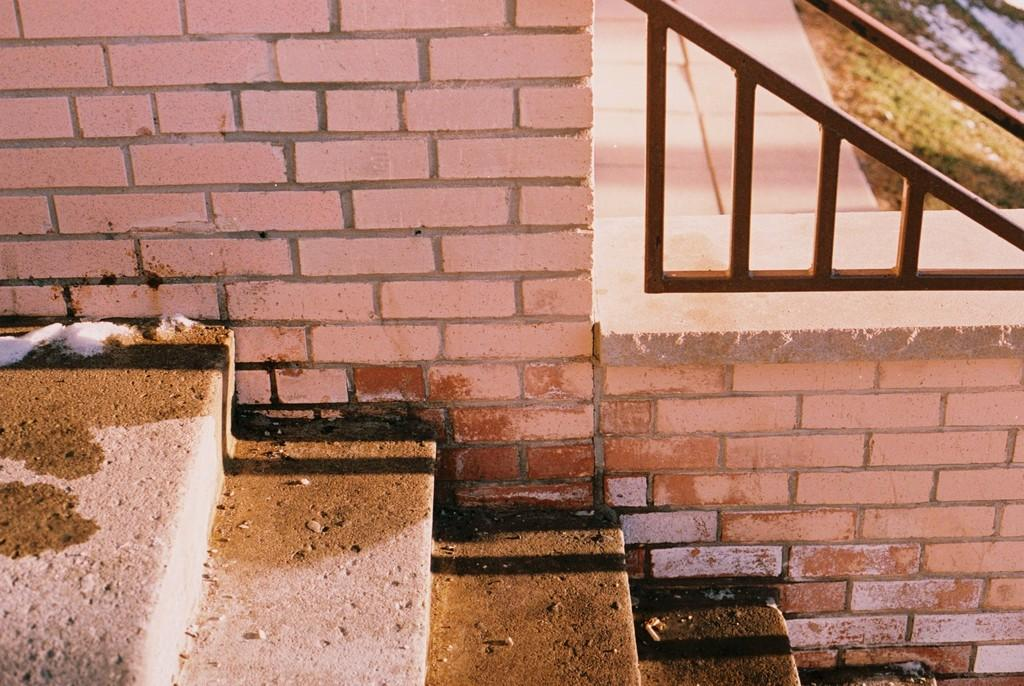What type of structure is visible in the image? There is a brick wall in the image. What architectural feature can be seen in the image? There are stairs in the image. Is there any safety feature present in the image? Yes, there is a railing in the image. What type of business is located near the brick wall in the image? There is no indication of a business in the image; it only features a brick wall, stairs, and a railing. Can you see any scissors or mailboxes in the image? No, there are no scissors or mailboxes present in the image. 